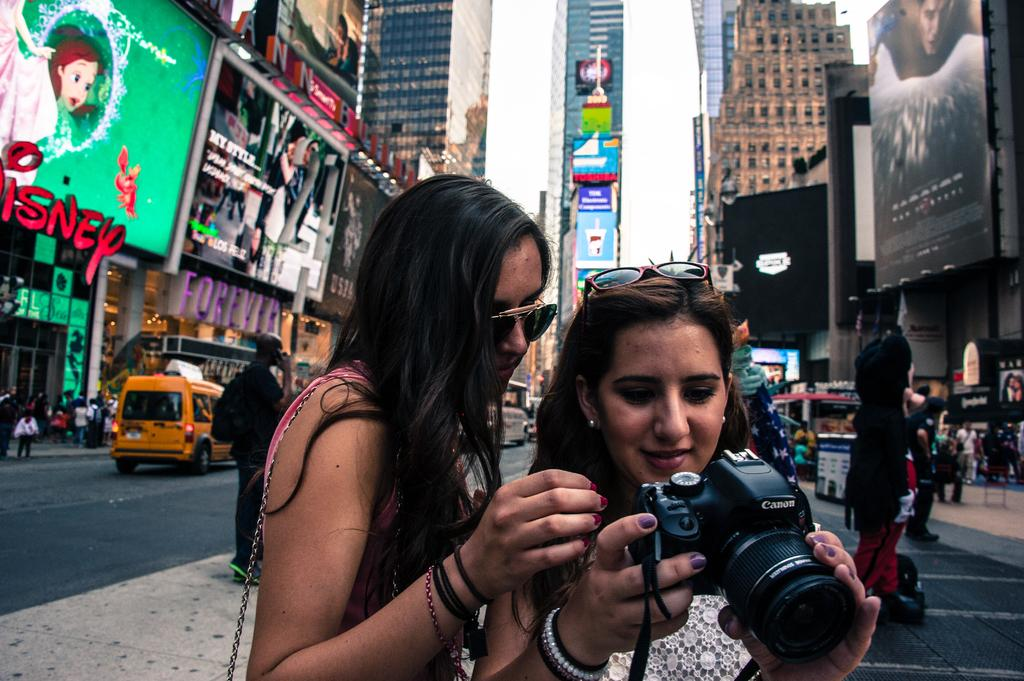<image>
Write a terse but informative summary of the picture. Two women looking at a camera with the word CANON on it. 